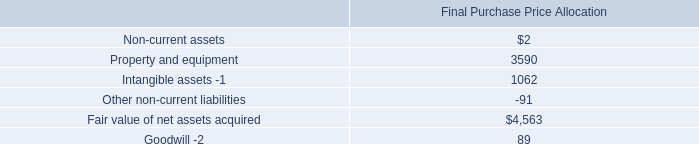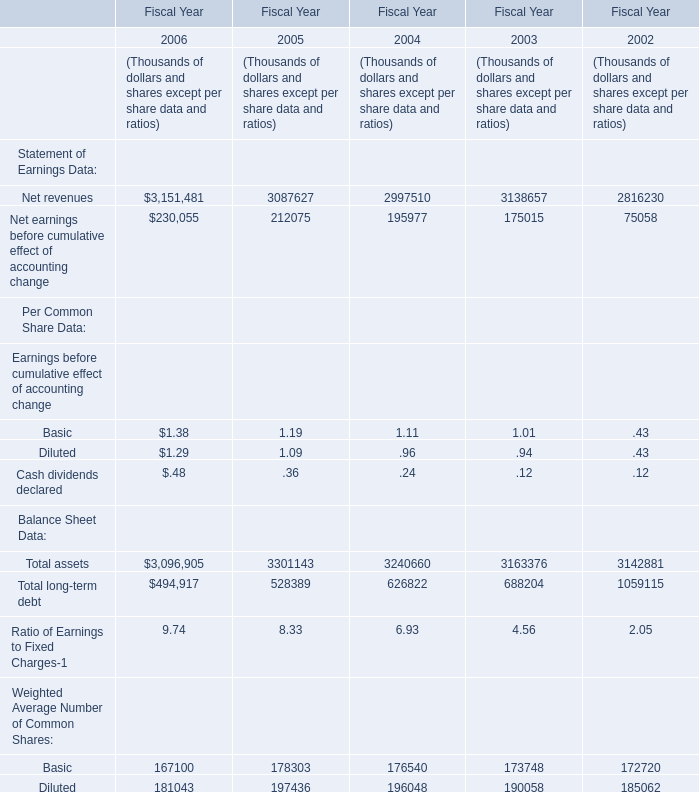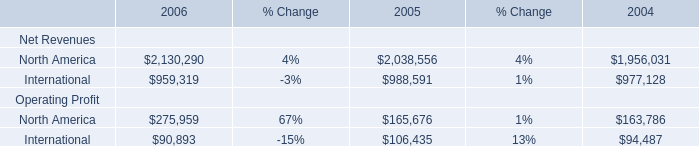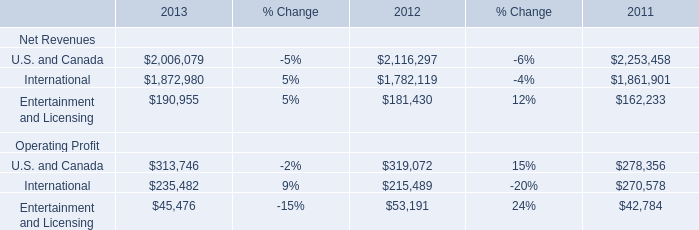What is the sum of Net revenues in 2003 and International of Net Revenues in 2013? (in thousand) 
Computations: (3138657 + 1872980)
Answer: 5011637.0. 